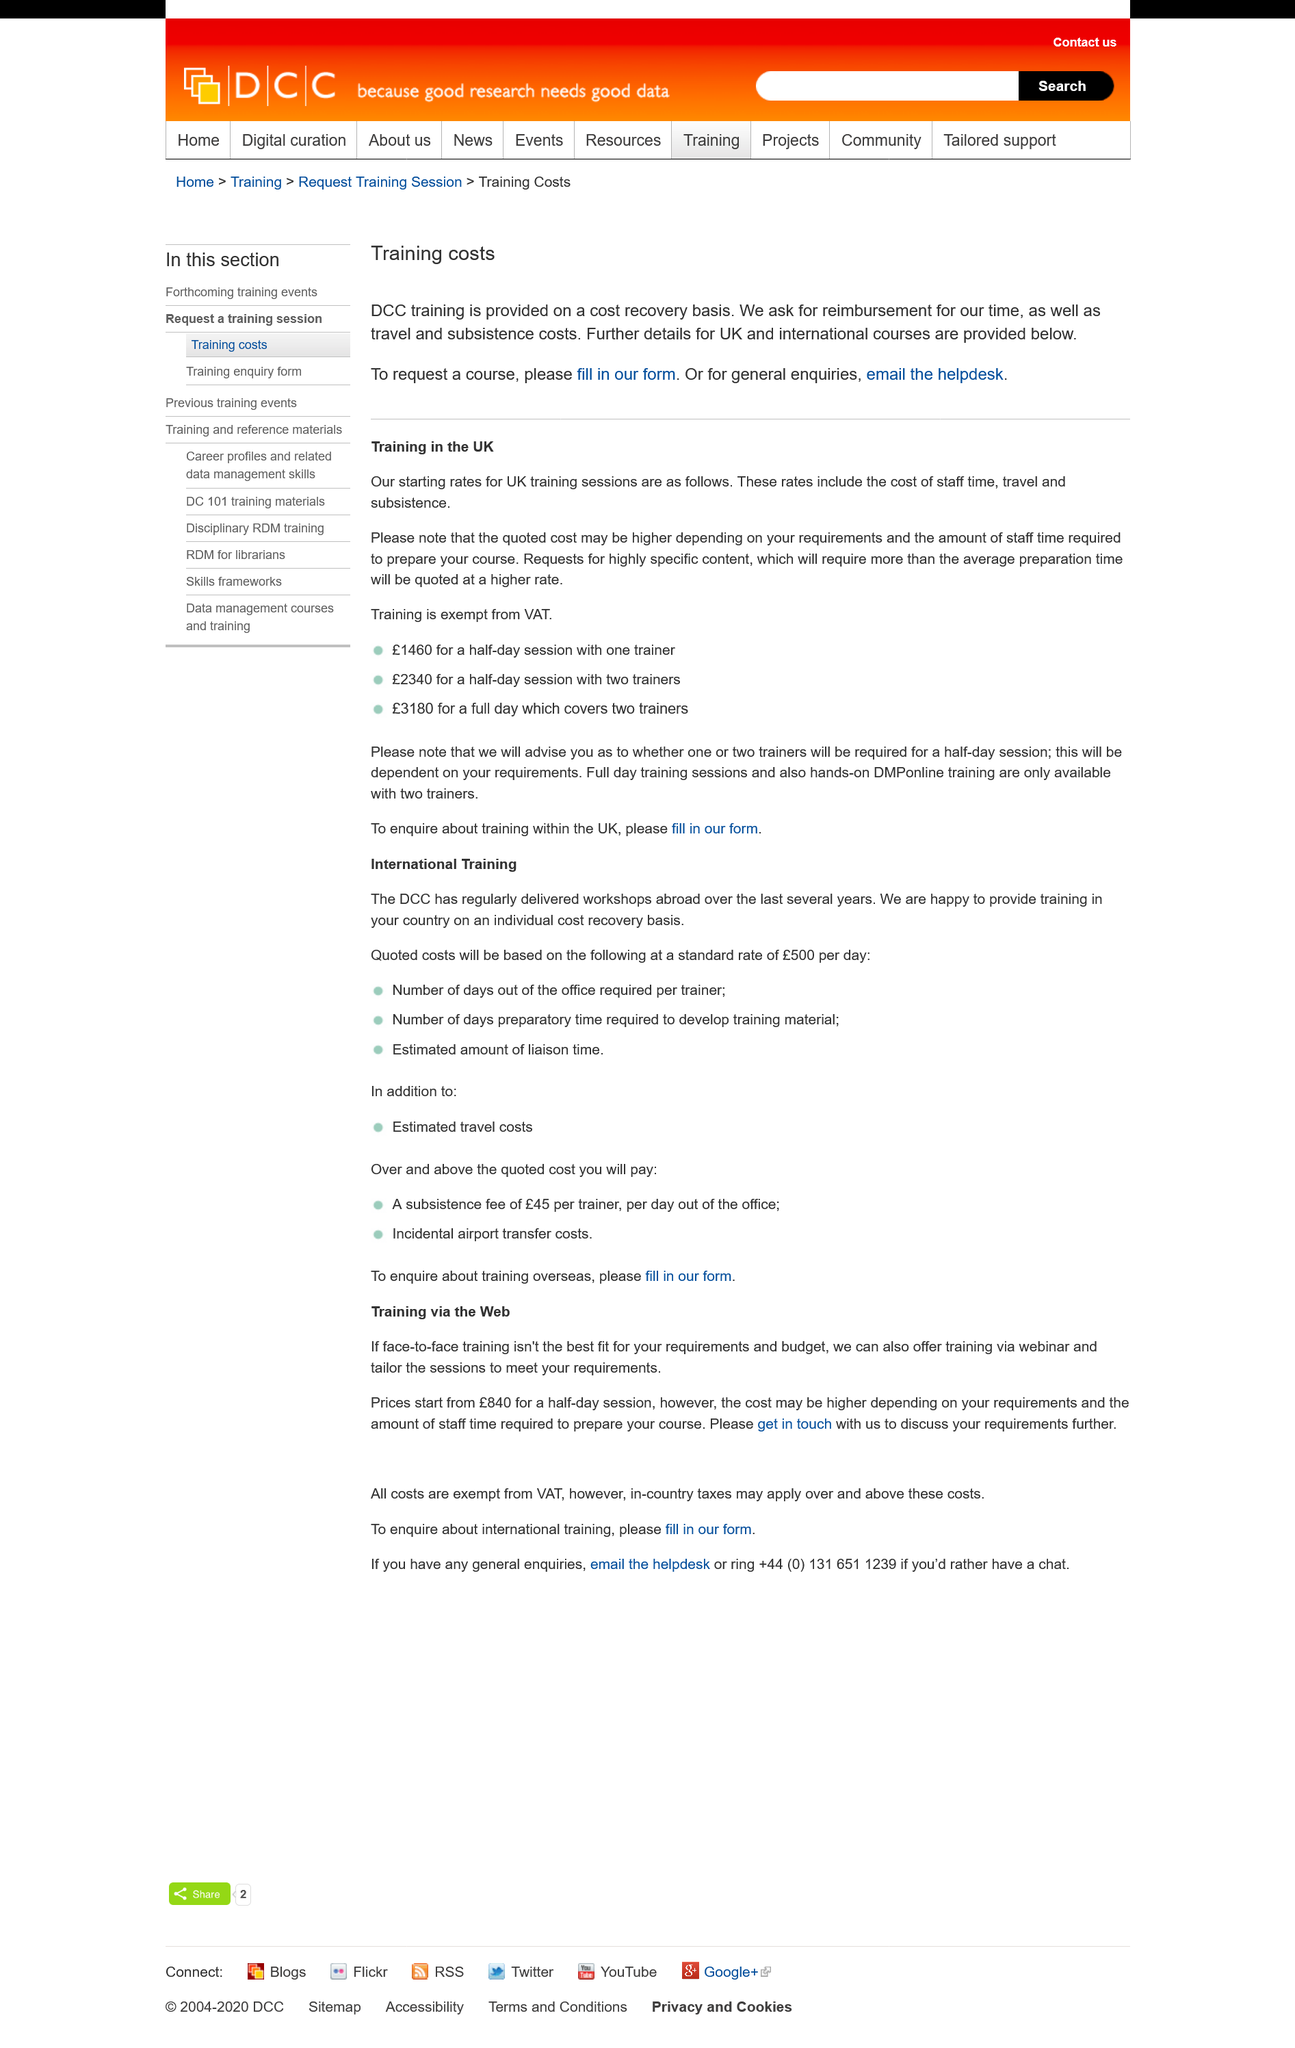Draw attention to some important aspects in this diagram. DCC training is funded through cost recovery and is not provided at no cost to the recipient. The quoted cost may be higher due to the requirements and the amount of staff time required to prepare the course. To request a course, please fill out the form provided on our website. For general enquiries, please email the helpdesk. Details for UK and international courses are available on our website. 